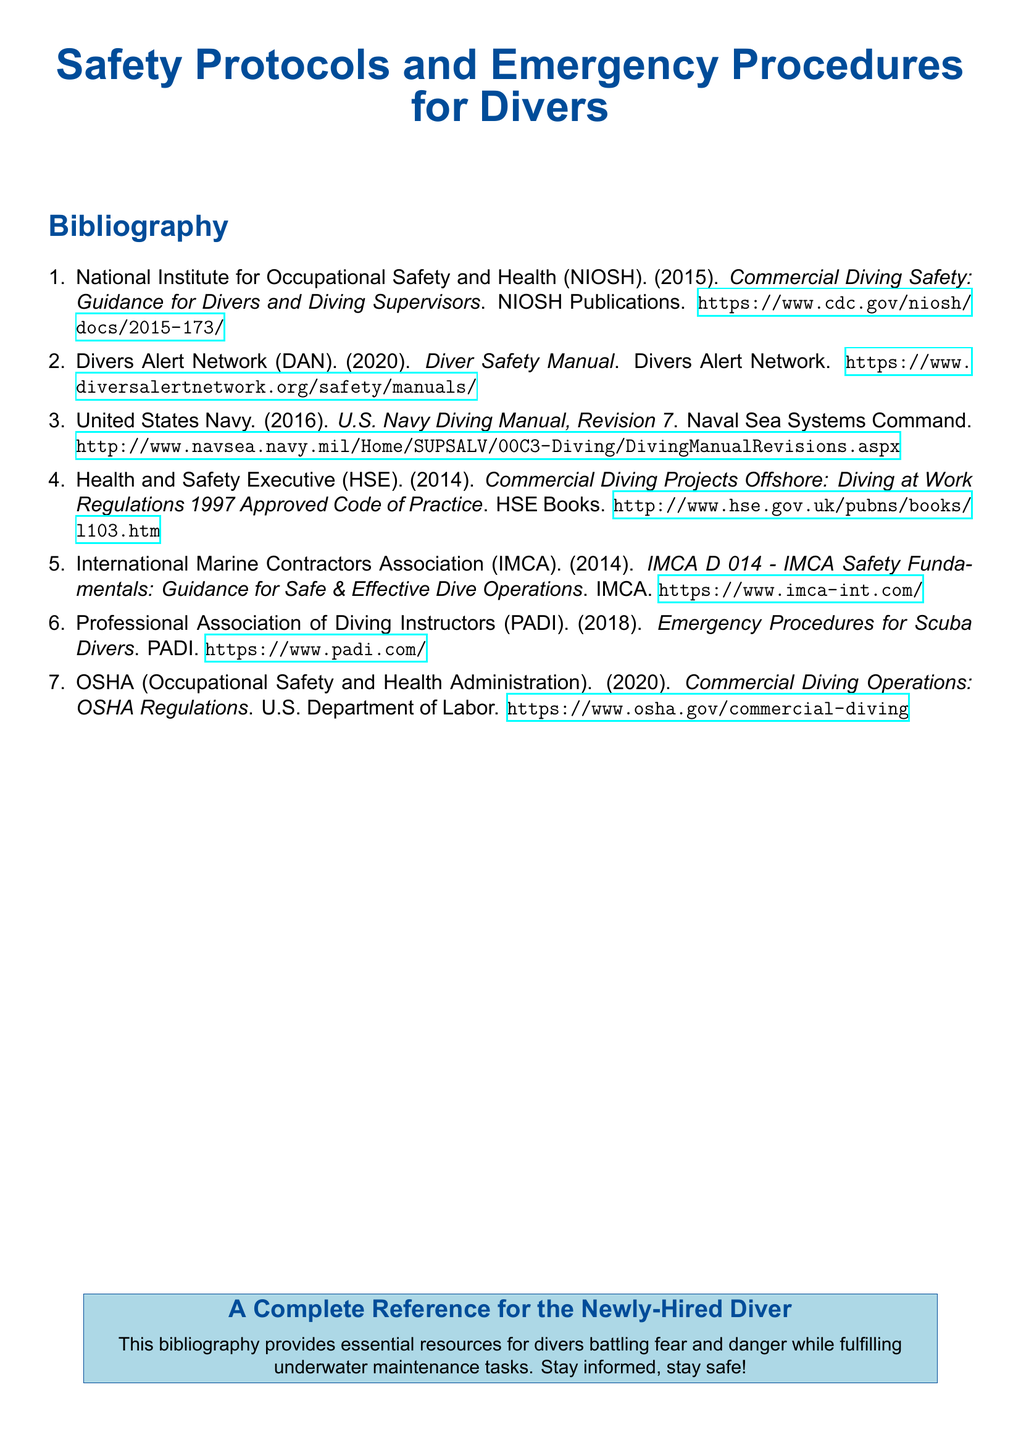What is the title of the document? The title, prominently displayed at the top, is "Safety Protocols and Emergency Procedures for Divers".
Answer: Safety Protocols and Emergency Procedures for Divers Who published the "Diver Safety Manual"? The document lists Divers Alert Network as the publisher of the "Diver Safety Manual."
Answer: Divers Alert Network What year was the "U.S. Navy Diving Manual, Revision 7" published? The publication date for the "U.S. Navy Diving Manual, Revision 7" is stated in the citation as 2016.
Answer: 2016 How many items are listed in the bibliography? The number of entries in the bibliography is indicated by the enumeration format, which shows seven items.
Answer: 7 Which organization provided the guidelines for safe dive operations? The citation for IMCA indicates that it provided guidance for safe and effective dive operations.
Answer: IMCA What is the URL for the "Commercial Diving Safety" guidance? The document provides a specific URL for this publication as part of the citation details.
Answer: https://www.cdc.gov/niosh/docs/2015-173/ What is the aim of the bibliography section? The bibliography section aims to provide resources for divers to stay informed and safe.
Answer: Stay informed, stay safe! 